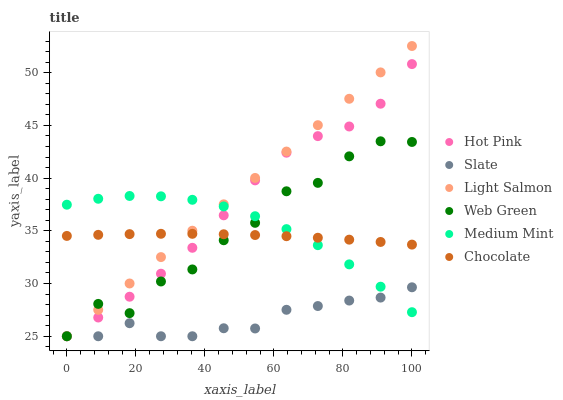Does Slate have the minimum area under the curve?
Answer yes or no. Yes. Does Light Salmon have the maximum area under the curve?
Answer yes or no. Yes. Does Light Salmon have the minimum area under the curve?
Answer yes or no. No. Does Slate have the maximum area under the curve?
Answer yes or no. No. Is Light Salmon the smoothest?
Answer yes or no. Yes. Is Web Green the roughest?
Answer yes or no. Yes. Is Slate the smoothest?
Answer yes or no. No. Is Slate the roughest?
Answer yes or no. No. Does Light Salmon have the lowest value?
Answer yes or no. Yes. Does Chocolate have the lowest value?
Answer yes or no. No. Does Light Salmon have the highest value?
Answer yes or no. Yes. Does Slate have the highest value?
Answer yes or no. No. Is Slate less than Chocolate?
Answer yes or no. Yes. Is Chocolate greater than Slate?
Answer yes or no. Yes. Does Light Salmon intersect Medium Mint?
Answer yes or no. Yes. Is Light Salmon less than Medium Mint?
Answer yes or no. No. Is Light Salmon greater than Medium Mint?
Answer yes or no. No. Does Slate intersect Chocolate?
Answer yes or no. No. 